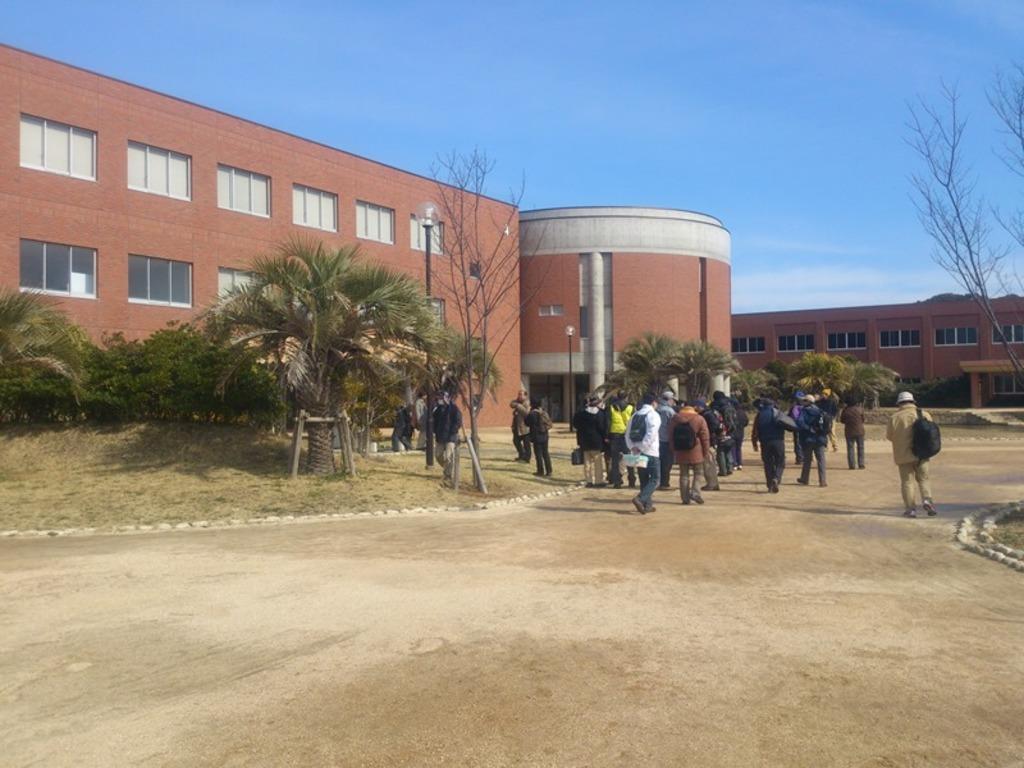In one or two sentences, can you explain what this image depicts? In the right side few people are walking on the way. In the left side there are trees, behind them, there is a building. At the top it's a sunny sky. 